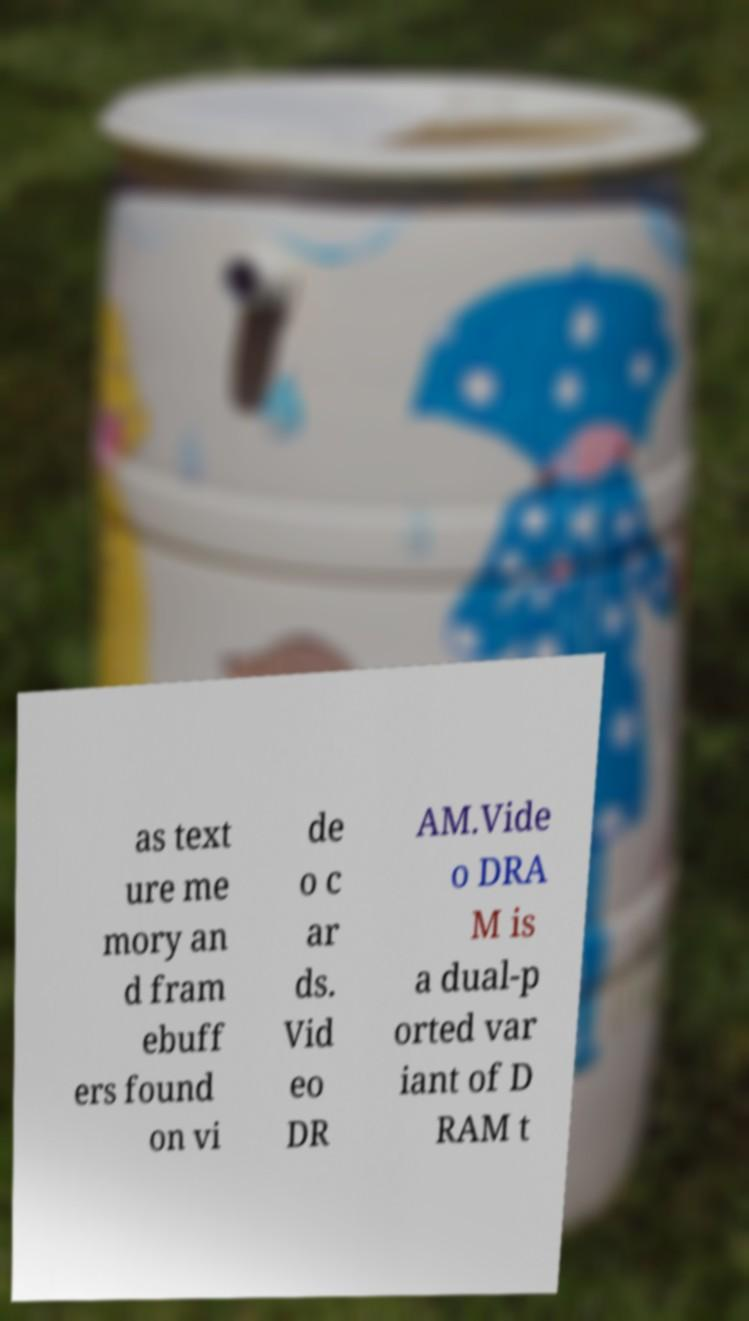Could you assist in decoding the text presented in this image and type it out clearly? as text ure me mory an d fram ebuff ers found on vi de o c ar ds. Vid eo DR AM.Vide o DRA M is a dual-p orted var iant of D RAM t 